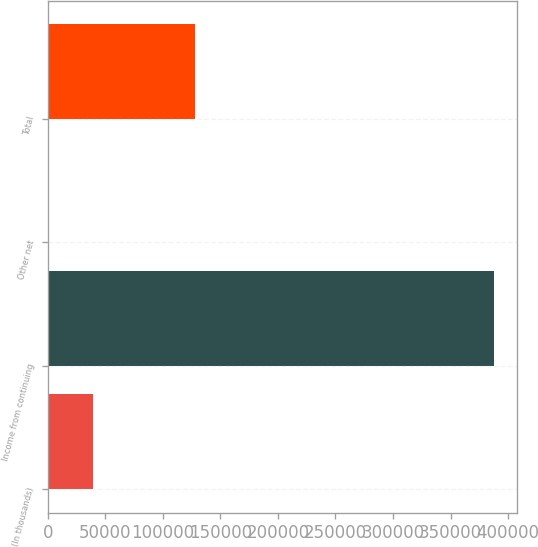<chart> <loc_0><loc_0><loc_500><loc_500><bar_chart><fcel>(In thousands)<fcel>Income from continuing<fcel>Other net<fcel>Total<nl><fcel>39056.5<fcel>387964<fcel>289<fcel>127809<nl></chart> 